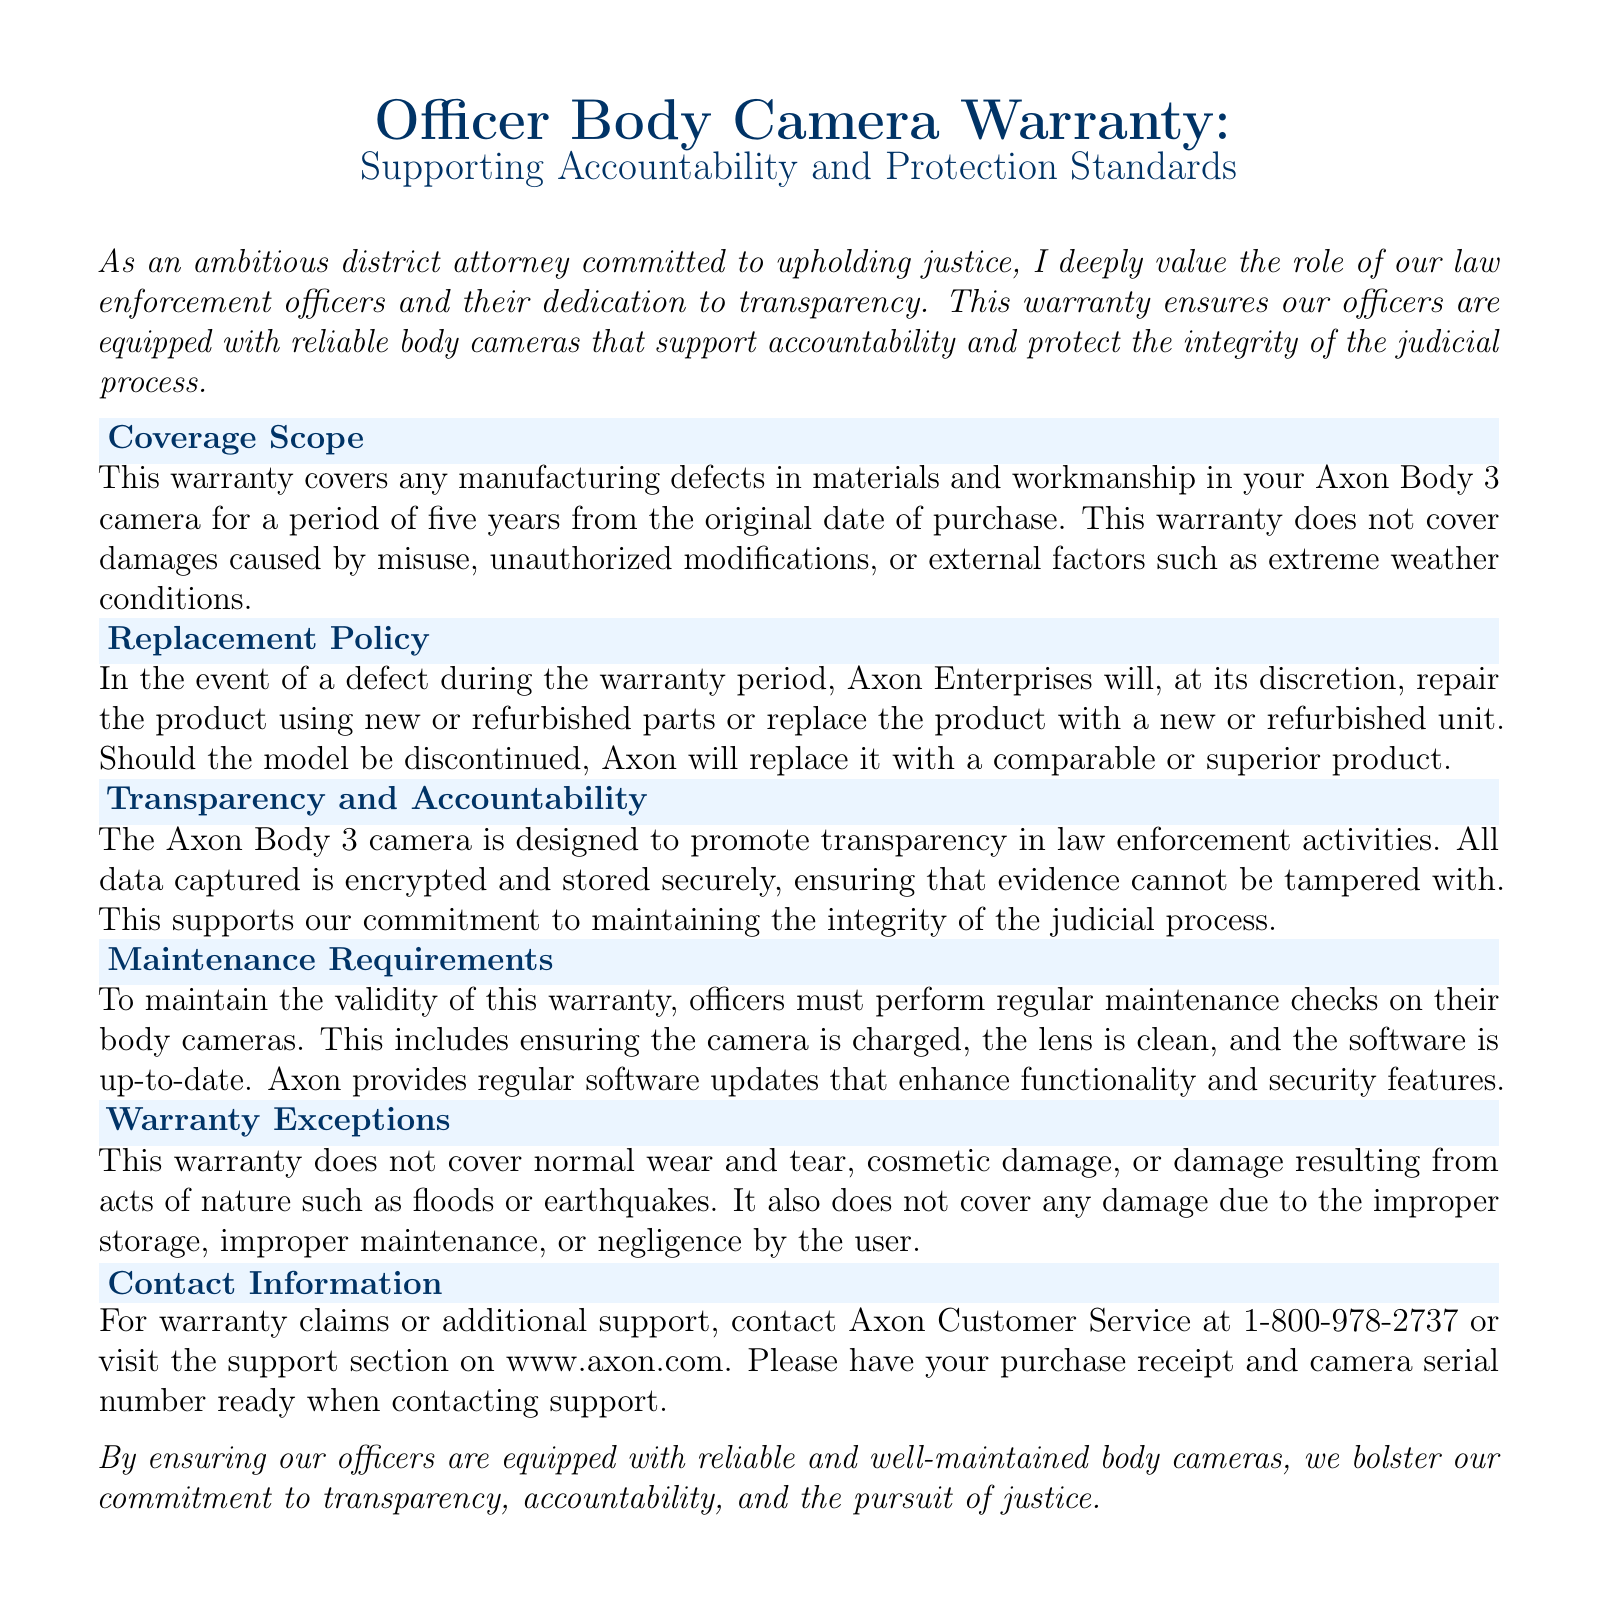What is the warranty period for the Axon Body 3 camera? The warranty period is five years from the original date of purchase.
Answer: five years What types of damages are not covered by the warranty? The warranty does not cover damages caused by misuse, unauthorized modifications, or external factors such as extreme weather conditions.
Answer: misuse or external factors What actions must officers take to maintain the warranty? Officers must perform regular maintenance checks, ensuring the camera is charged, the lens is clean, and the software is up-to-date.
Answer: regular maintenance checks What does Axon do if the model is discontinued? Axon will replace it with a comparable or superior product.
Answer: comparable or superior product What is the contact number for warranty claims? The contact number for warranty claims is provided in the document.
Answer: 1-800-978-2737 What is the purpose of the Axon Body 3 camera according to the document? The purpose of the camera is to promote transparency in law enforcement activities.
Answer: promote transparency What type of damage is explicitly covered by the warranty? The warranty covers manufacturing defects in materials and workmanship.
Answer: manufacturing defects What should be ready when contacting Axon Customer Service? Customers should have their purchase receipt and camera serial number ready.
Answer: purchase receipt and camera serial number What kind of updates does Axon provide for the cameras? Axon provides regular software updates that enhance functionality and security features.
Answer: regular software updates 